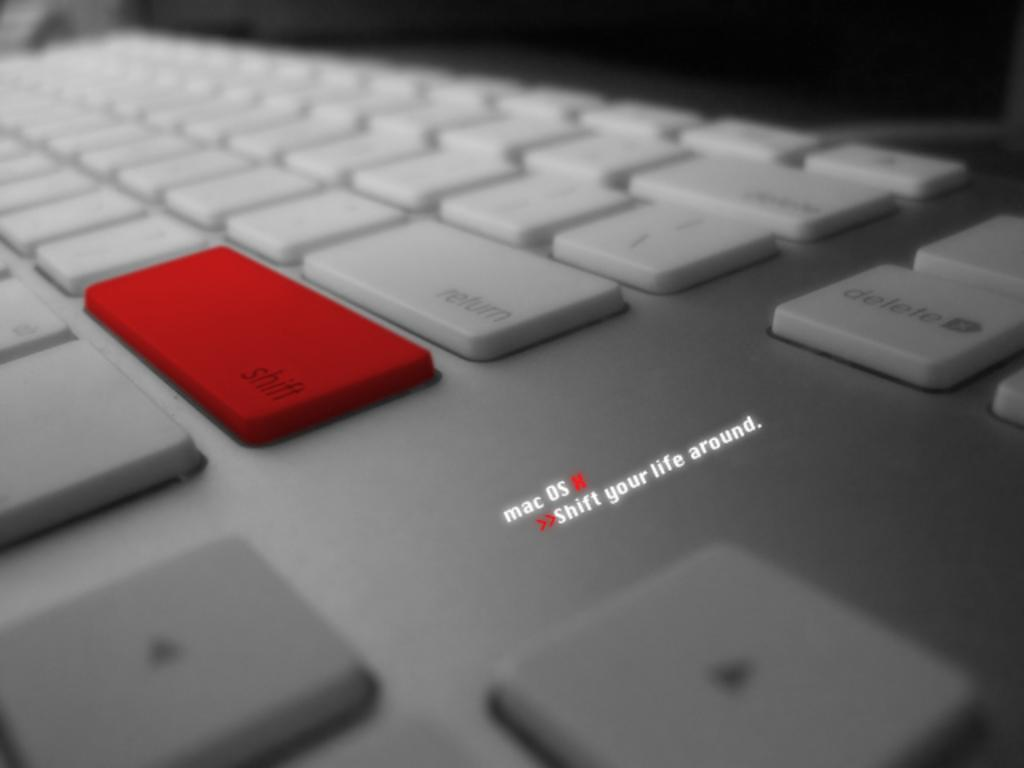<image>
Summarize the visual content of the image. a keyboard with white keys except for a red shift key 